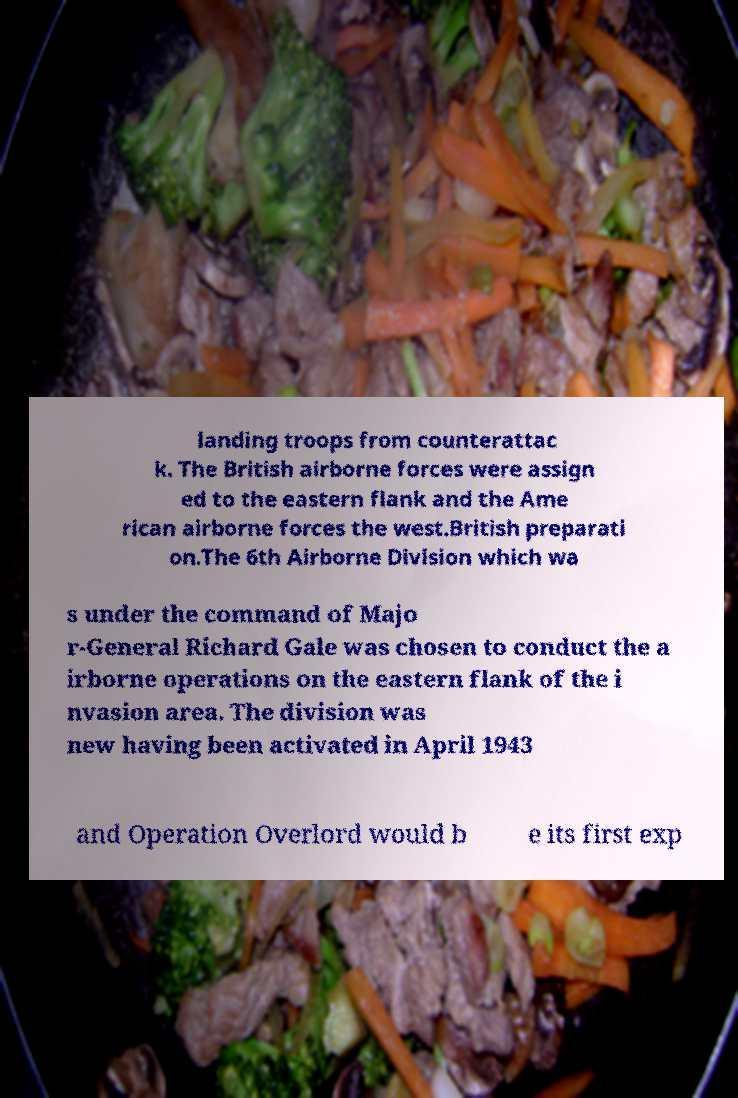There's text embedded in this image that I need extracted. Can you transcribe it verbatim? landing troops from counterattac k. The British airborne forces were assign ed to the eastern flank and the Ame rican airborne forces the west.British preparati on.The 6th Airborne Division which wa s under the command of Majo r-General Richard Gale was chosen to conduct the a irborne operations on the eastern flank of the i nvasion area. The division was new having been activated in April 1943 and Operation Overlord would b e its first exp 